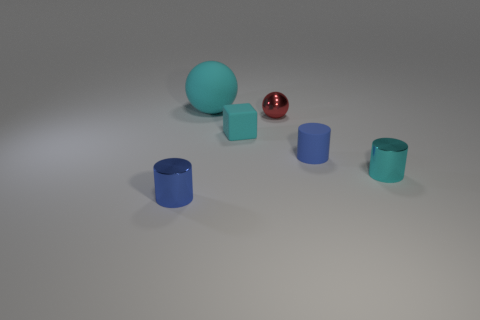Add 1 large red shiny balls. How many objects exist? 7 Subtract all spheres. How many objects are left? 4 Subtract all blue rubber blocks. Subtract all tiny shiny things. How many objects are left? 3 Add 3 small cyan shiny cylinders. How many small cyan shiny cylinders are left? 4 Add 1 shiny things. How many shiny things exist? 4 Subtract 0 red blocks. How many objects are left? 6 